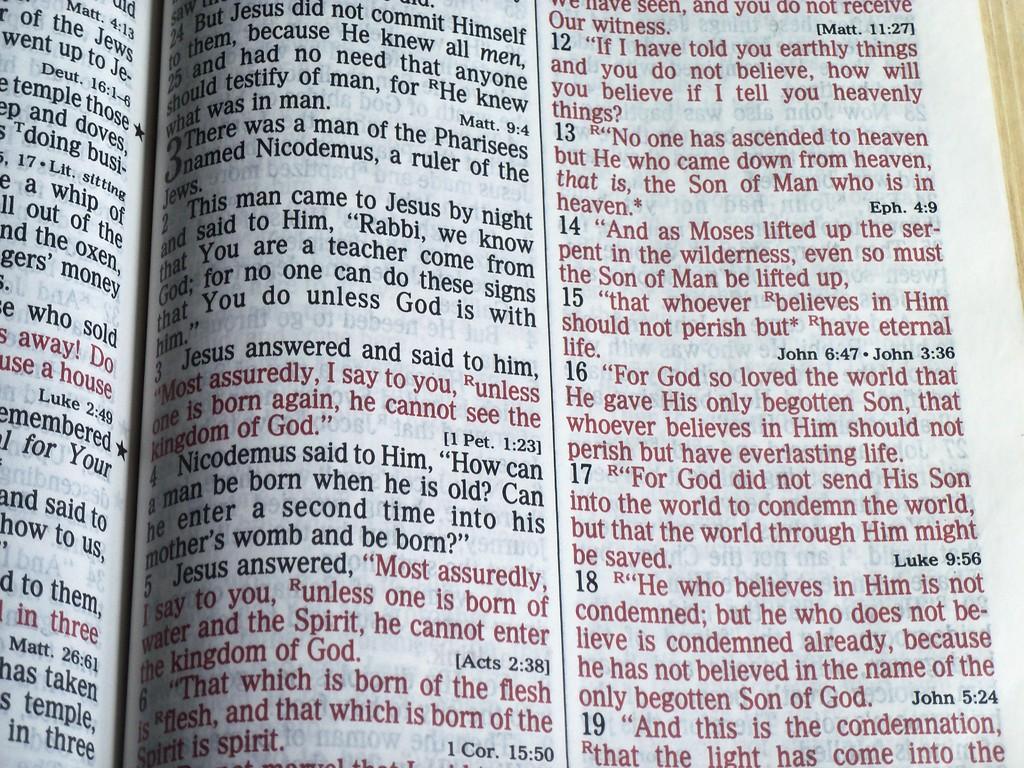What is the verse number on the very top right?
Your response must be concise. 12. 